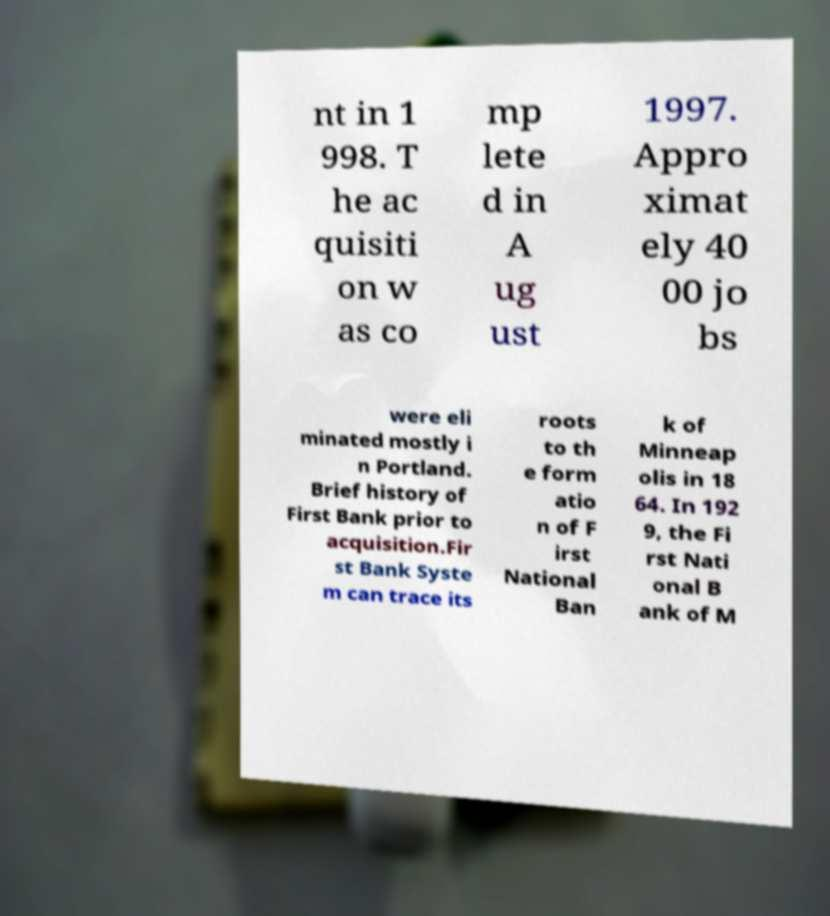Please read and relay the text visible in this image. What does it say? nt in 1 998. T he ac quisiti on w as co mp lete d in A ug ust 1997. Appro ximat ely 40 00 jo bs were eli minated mostly i n Portland. Brief history of First Bank prior to acquisition.Fir st Bank Syste m can trace its roots to th e form atio n of F irst National Ban k of Minneap olis in 18 64. In 192 9, the Fi rst Nati onal B ank of M 